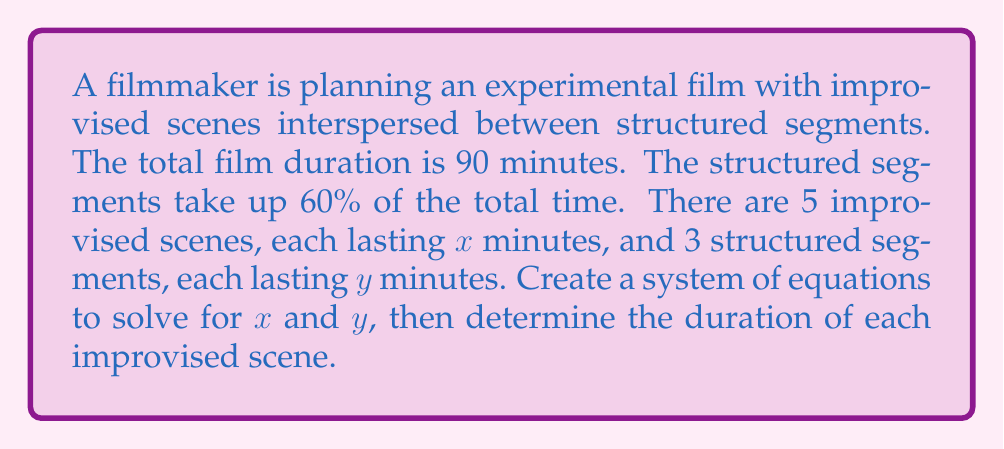What is the answer to this math problem? Let's approach this step-by-step:

1) First, we need to set up our system of equations based on the given information:

   Equation 1: Total time equation
   $$5x + 3y = 90$$

   Equation 2: Structured segments time equation
   $$3y = 0.6 \cdot 90 = 54$$

2) From Equation 2, we can immediately solve for $y$:
   $$y = 54 \div 3 = 18$$

3) Now that we know $y$, we can substitute this value into Equation 1:
   $$5x + 3(18) = 90$$
   $$5x + 54 = 90$$

4) Solve for $x$:
   $$5x = 90 - 54 = 36$$
   $$x = 36 \div 5 = 7.2$$

5) Therefore, each improvised scene lasts 7.2 minutes.
Answer: 7.2 minutes 